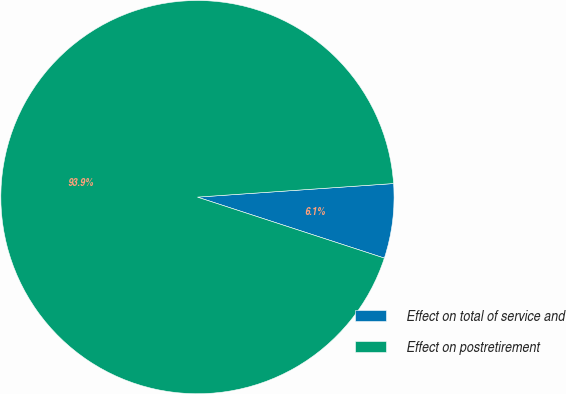Convert chart to OTSL. <chart><loc_0><loc_0><loc_500><loc_500><pie_chart><fcel>Effect on total of service and<fcel>Effect on postretirement<nl><fcel>6.12%<fcel>93.88%<nl></chart> 